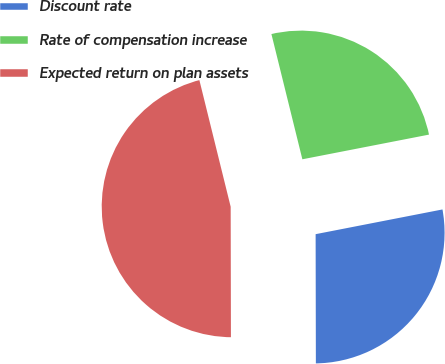<chart> <loc_0><loc_0><loc_500><loc_500><pie_chart><fcel>Discount rate<fcel>Rate of compensation increase<fcel>Expected return on plan assets<nl><fcel>28.03%<fcel>25.79%<fcel>46.17%<nl></chart> 